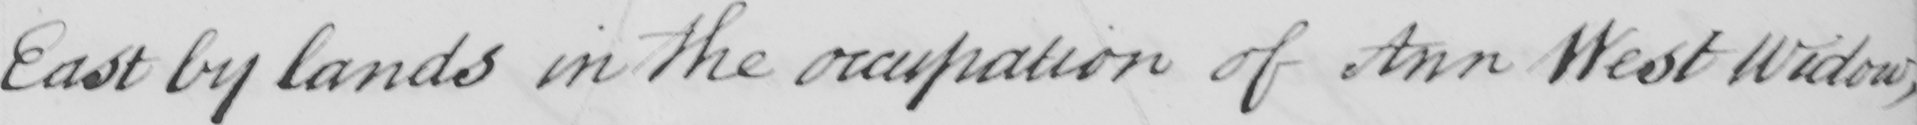Can you read and transcribe this handwriting? East by lands in the occupation of Ann West Widow , 